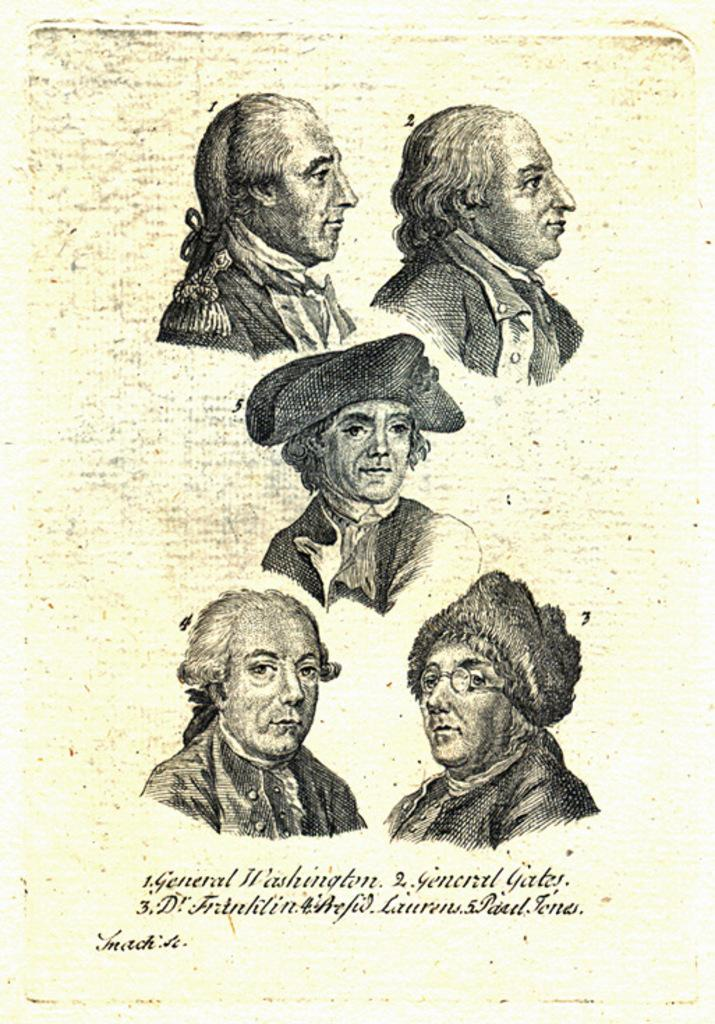What is depicted on the paper in the image? There are pictures of five persons on a paper. What else can be seen at the bottom of the paper? There is text written at the bottom of the paper. What type of harmony can be seen between the nut and the ray in the image? There is no nut or ray present in the image; it only features pictures of five persons and text on a paper. 